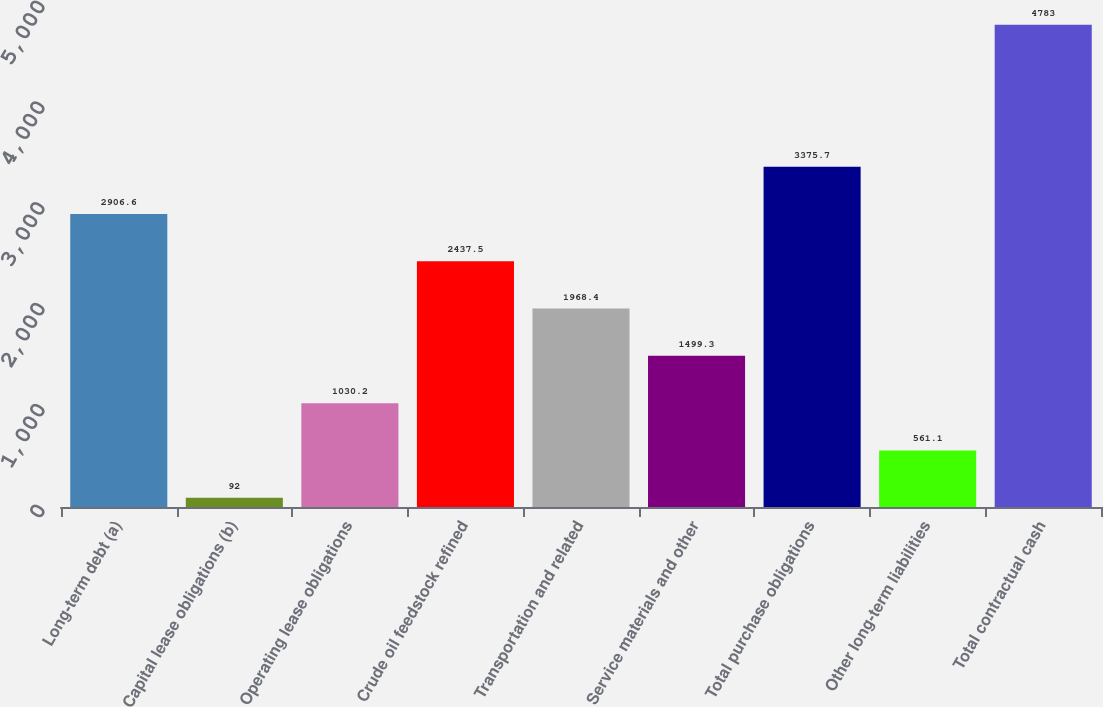Convert chart. <chart><loc_0><loc_0><loc_500><loc_500><bar_chart><fcel>Long-term debt (a)<fcel>Capital lease obligations (b)<fcel>Operating lease obligations<fcel>Crude oil feedstock refined<fcel>Transportation and related<fcel>Service materials and other<fcel>Total purchase obligations<fcel>Other long-term liabilities<fcel>Total contractual cash<nl><fcel>2906.6<fcel>92<fcel>1030.2<fcel>2437.5<fcel>1968.4<fcel>1499.3<fcel>3375.7<fcel>561.1<fcel>4783<nl></chart> 